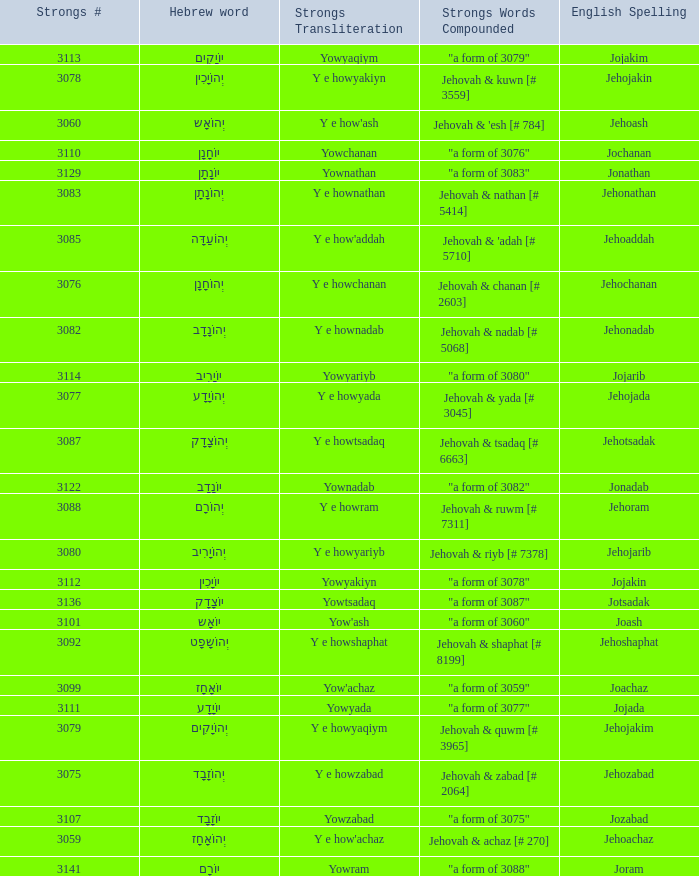What is the strong words compounded when the strongs transliteration is yowyariyb? "a form of 3080". 